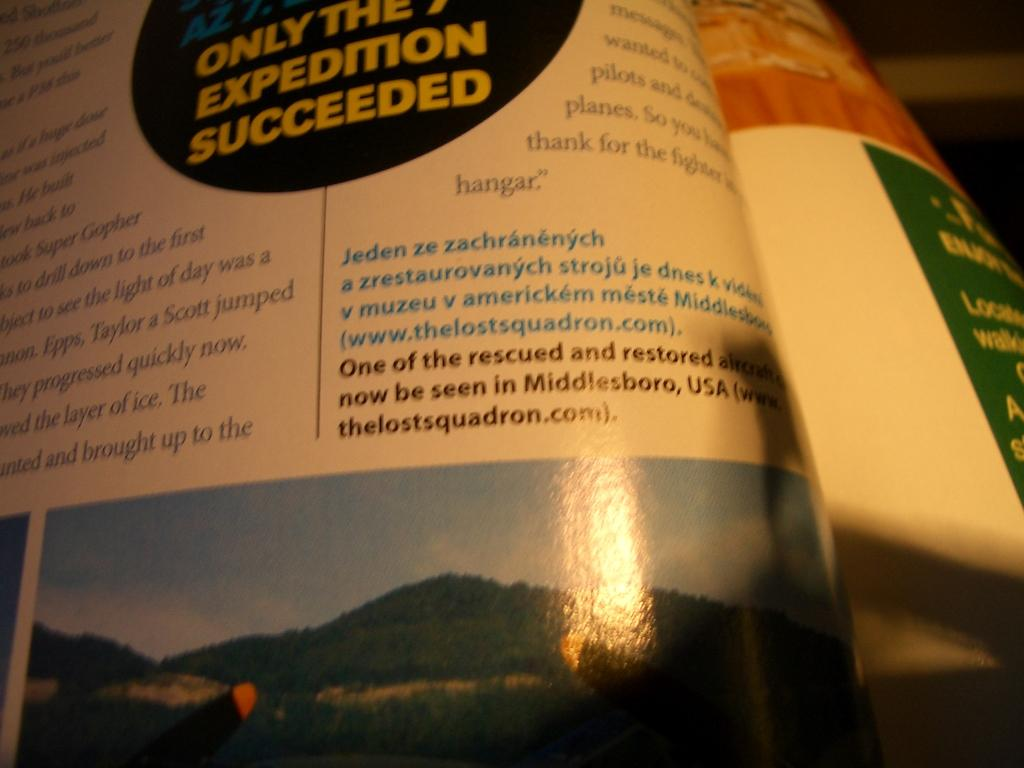<image>
Give a short and clear explanation of the subsequent image. a glossy page that says expedition succeeded in the center circle 